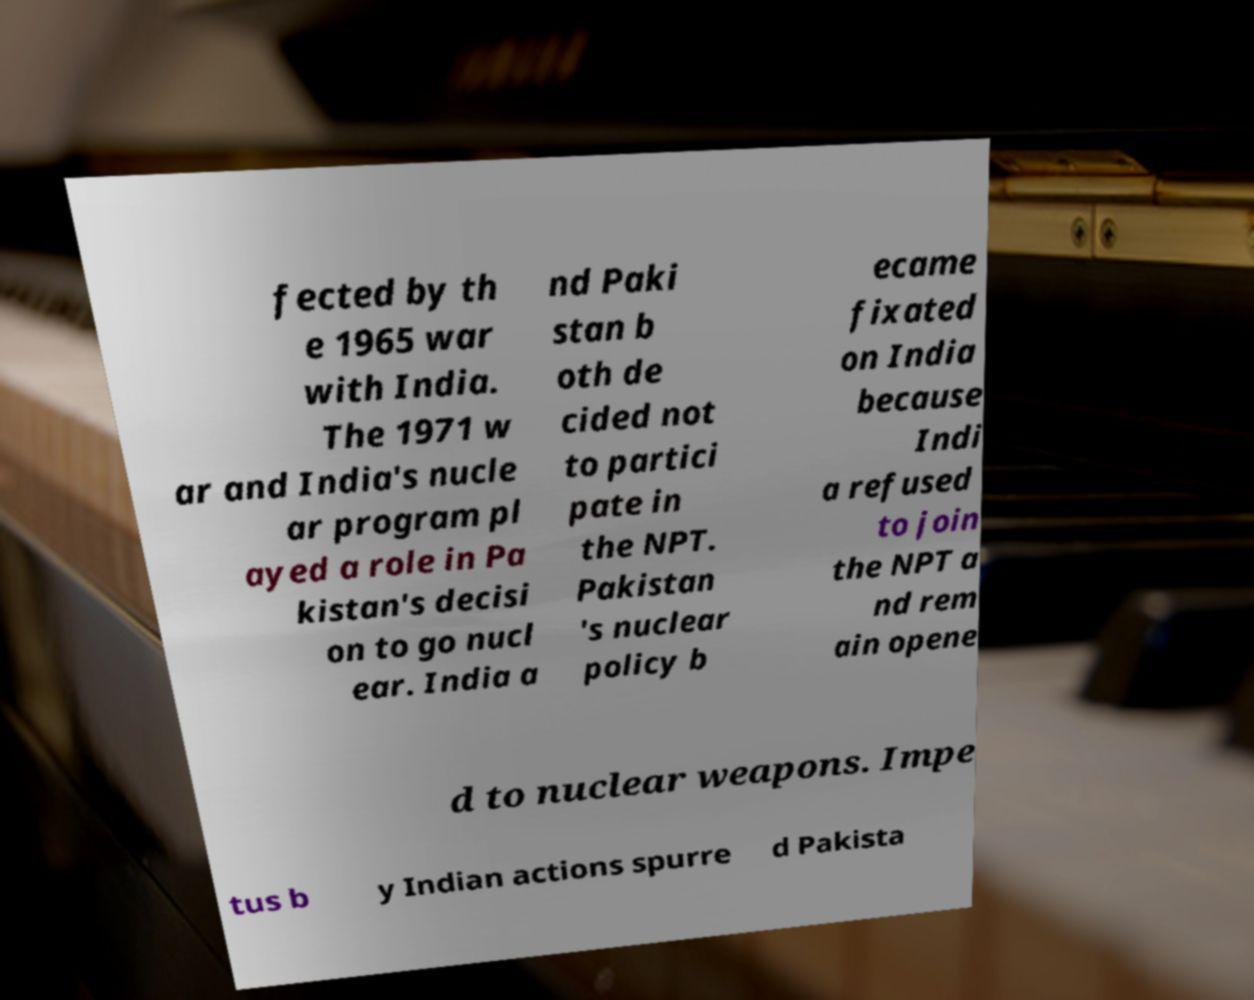Please read and relay the text visible in this image. What does it say? fected by th e 1965 war with India. The 1971 w ar and India's nucle ar program pl ayed a role in Pa kistan's decisi on to go nucl ear. India a nd Paki stan b oth de cided not to partici pate in the NPT. Pakistan 's nuclear policy b ecame fixated on India because Indi a refused to join the NPT a nd rem ain opene d to nuclear weapons. Impe tus b y Indian actions spurre d Pakista 